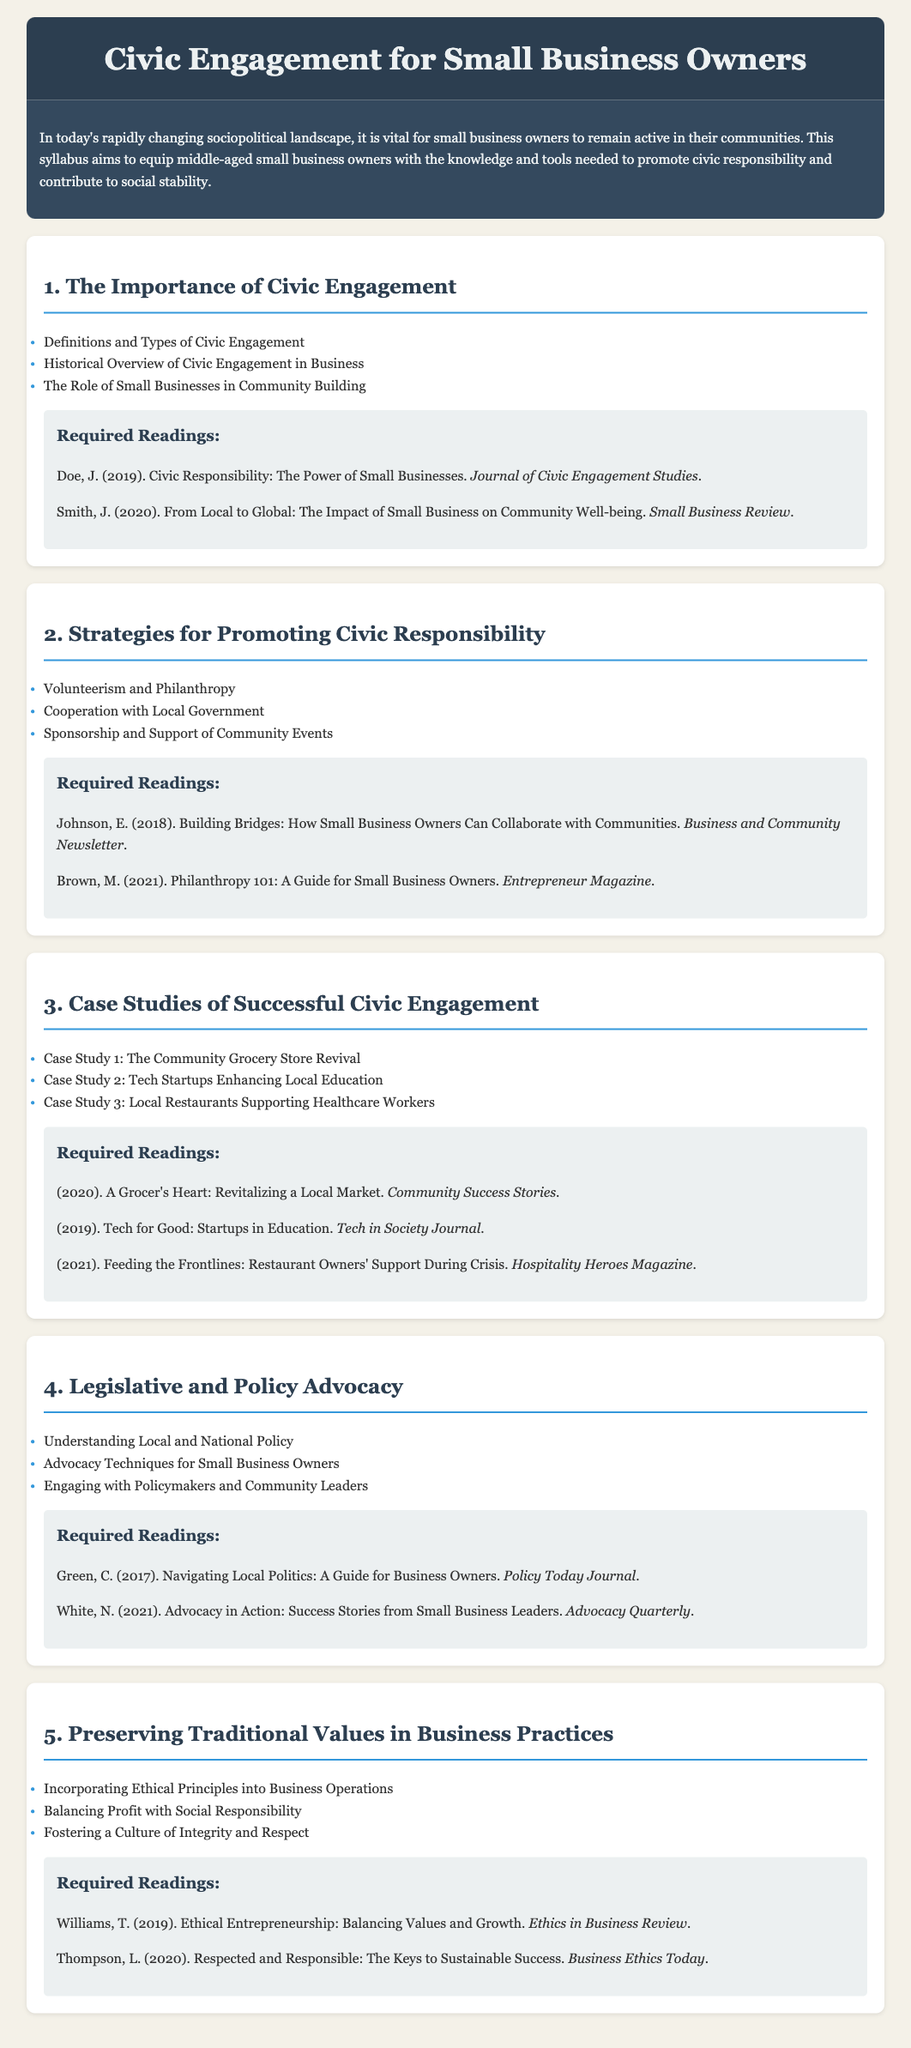What is the title of the syllabus? The title is prominently displayed at the top of the document, indicating the focus of the content.
Answer: Civic Engagement for Small Business Owners How many sections are in the syllabus? Each section is clearly numbered and titled, making it easy to count.
Answer: Five What is one of the required readings in Section 1? The specific reading titles are listed under each section, allowing for straightforward identification.
Answer: Doe, J. (2019). Civic Responsibility: The Power of Small Businesses Who is the author of a required reading in Section 4? Each reading includes the author's name, and Section 4 has multiple listed readings.
Answer: Green, C What is a key topic in Section 5? The key topics are listed in bullet points, summarizing the main ideas in each section.
Answer: Incorporating Ethical Principles into Business Operations What year was the reading by Thompson published? The year of publication is included in the required readings section for clarity.
Answer: 2020 What advocacy topic is discussed in Section 4? The specific topics related to advocacy provide insights into what small business owners can learn.
Answer: Advocacy Techniques for Small Business Owners What is a case study topic mentioned in Section 3? Case study topics are listed and represent real-world examples relevant to the syllabus.
Answer: The Community Grocery Store Revival What is a strategy mentioned in Section 2? Strategies for civic responsibility are presented as bullet points for easy reference.
Answer: Volunteerism and Philanthropy 